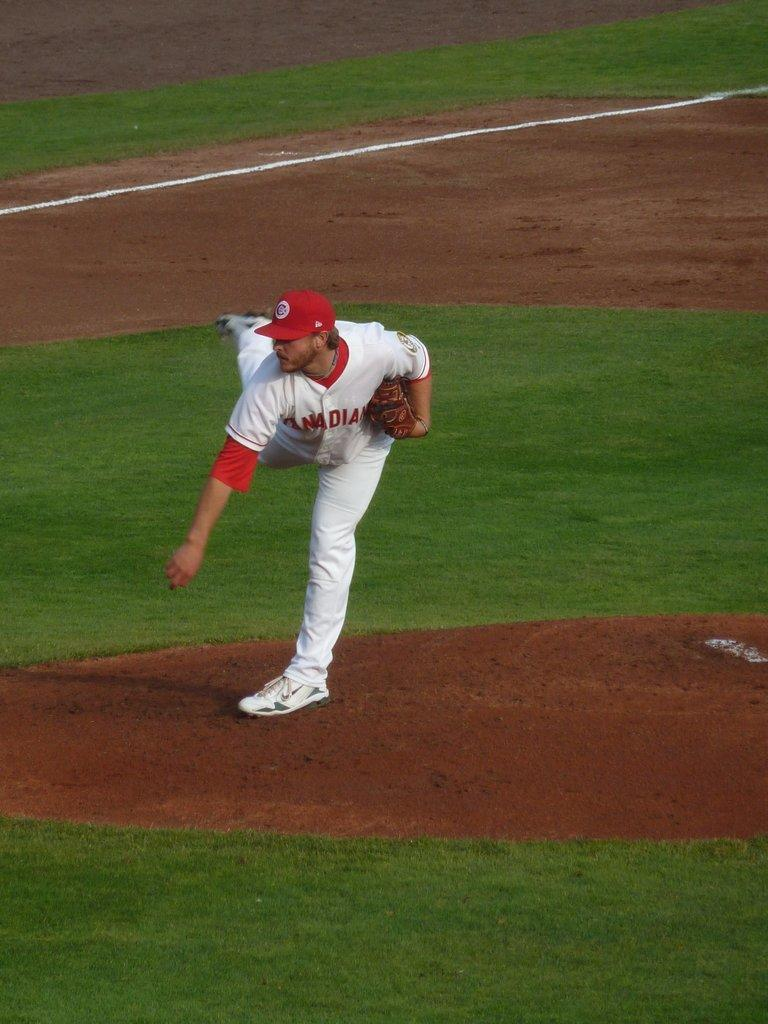Provide a one-sentence caption for the provided image. The Canadian pitcher has just delivered a pitch from the mound. 